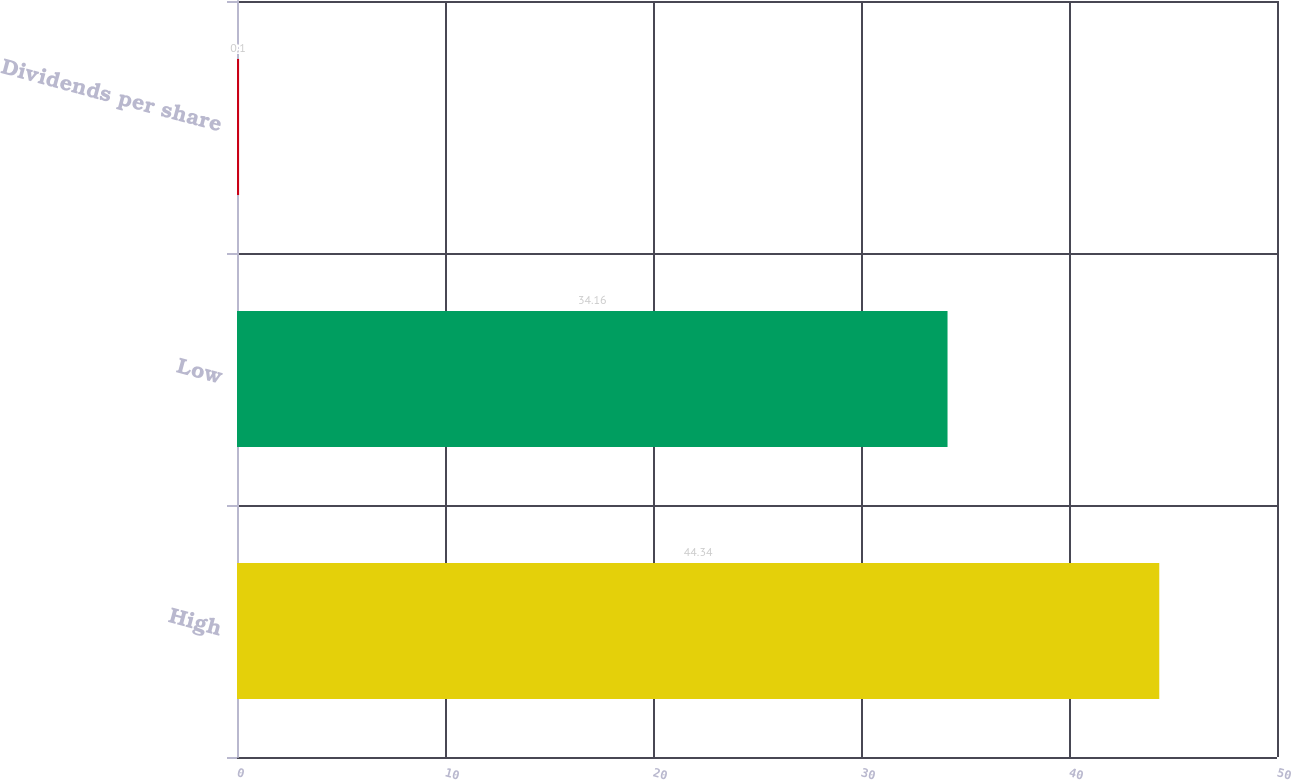Convert chart to OTSL. <chart><loc_0><loc_0><loc_500><loc_500><bar_chart><fcel>High<fcel>Low<fcel>Dividends per share<nl><fcel>44.34<fcel>34.16<fcel>0.1<nl></chart> 